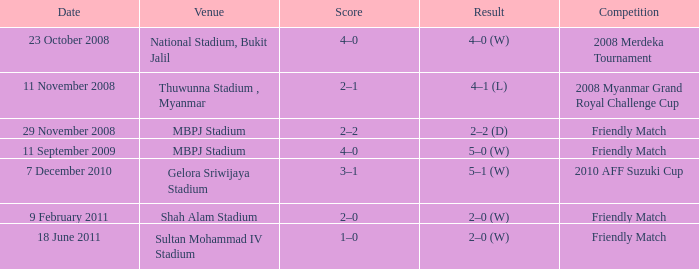What Competition had a Score of 2–0? Friendly Match. 